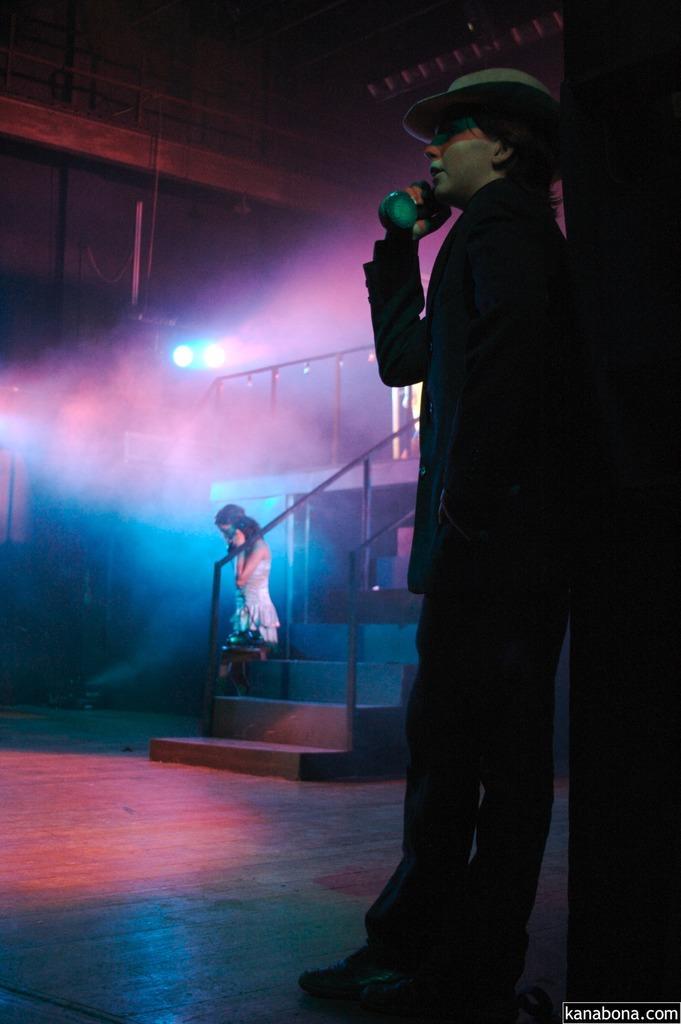Please provide a concise description of this image. In this image there is a man standing near to the pillar, in the background there are steps, beside the steps there is a girl and there is a light, in the bottom right there is text. 